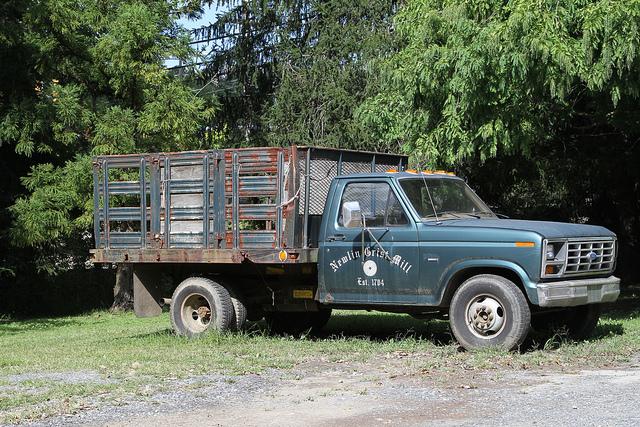Is this truck used often?
Write a very short answer. Yes. What kind of truck is pictured?
Answer briefly. Ford. What is this?
Write a very short answer. Truck. How many tires are on the green truck?
Be succinct. 6. What color is the truck body?
Concise answer only. Blue. What is the logo on the side of the truck?
Concise answer only. Newlin grist mill. What color is the bumper?
Give a very brief answer. Gray. Does the truck look abandoned?
Answer briefly. Yes. How many tires can you see?
Be succinct. 3. Is this a fleet?
Give a very brief answer. No. How many lights are on the truck?
Keep it brief. 2. How many wheels does the green truck have?
Answer briefly. 6. Where is the truck located?
Answer briefly. Grass. What is the background of this photo?
Give a very brief answer. Trees. 